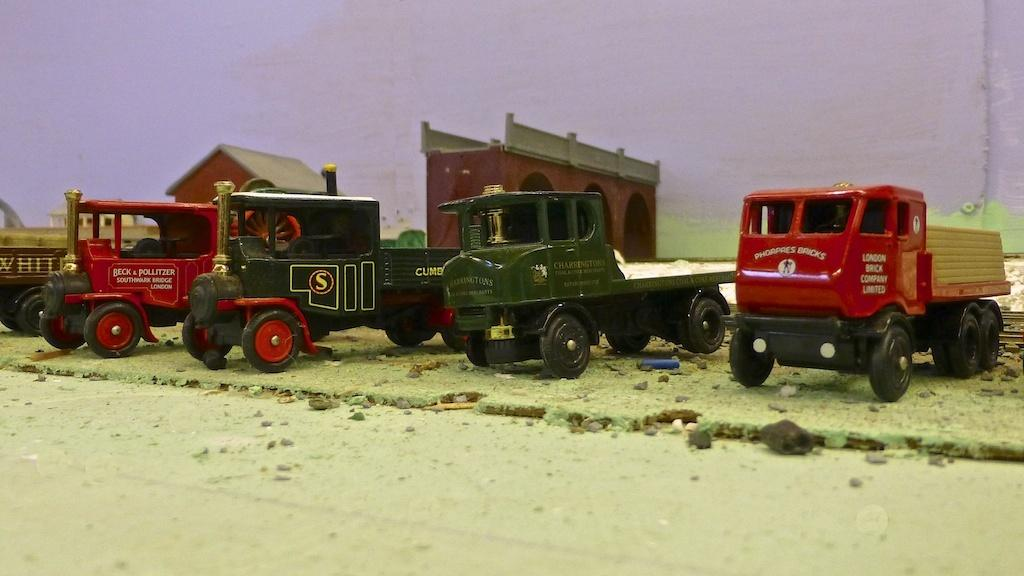What types of toys are present in the image? There are toys of vehicles and houses in the image. Where are the toys located? The toys are on a surface in the image. What can be seen in the background of the image? There is a wall in the background of the image. What type of stone can be seen in the image? There is no stone present in the image; it features toys of vehicles and houses on a surface with a wall in the background. 